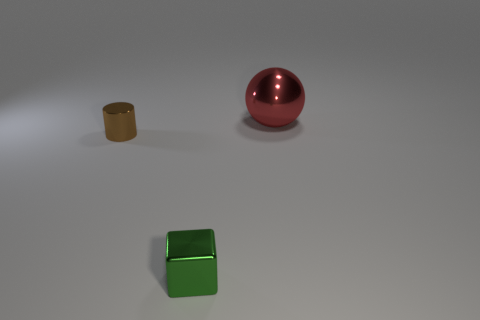Add 1 tiny blue rubber blocks. How many objects exist? 4 Subtract all yellow balls. How many red cubes are left? 0 Subtract all green shiny objects. Subtract all big objects. How many objects are left? 1 Add 3 brown shiny things. How many brown shiny things are left? 4 Add 2 cyan metal cylinders. How many cyan metal cylinders exist? 2 Subtract 0 cyan spheres. How many objects are left? 3 Subtract all cylinders. How many objects are left? 2 Subtract all purple cylinders. Subtract all brown cubes. How many cylinders are left? 1 